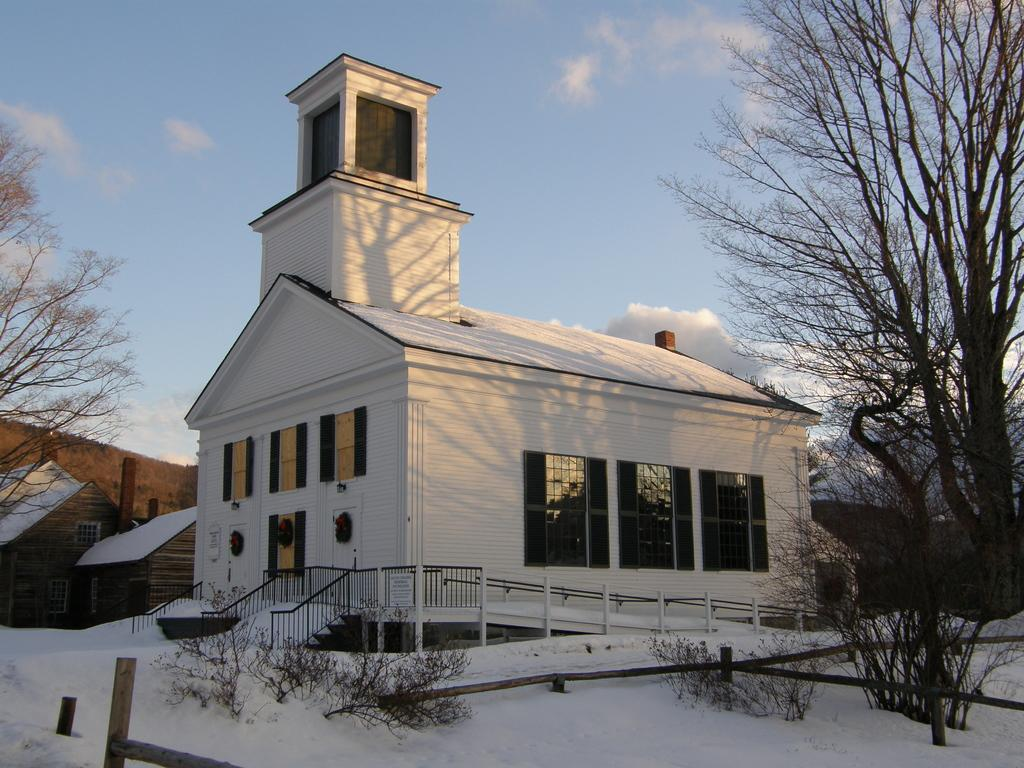What type of weather is depicted in the image? There is snow in the image, indicating cold weather. What type of vegetation can be seen in the image? There are plants and trees in the image. What architectural feature is present in the image? There are iron grilles in the image. What type of structures are visible in the image? There are houses in the image. What is visible in the background of the image? The sky is visible in the background of the image. What type of silk clothing is the fireman wearing in the image? There is no fireman or silk clothing present in the image. 